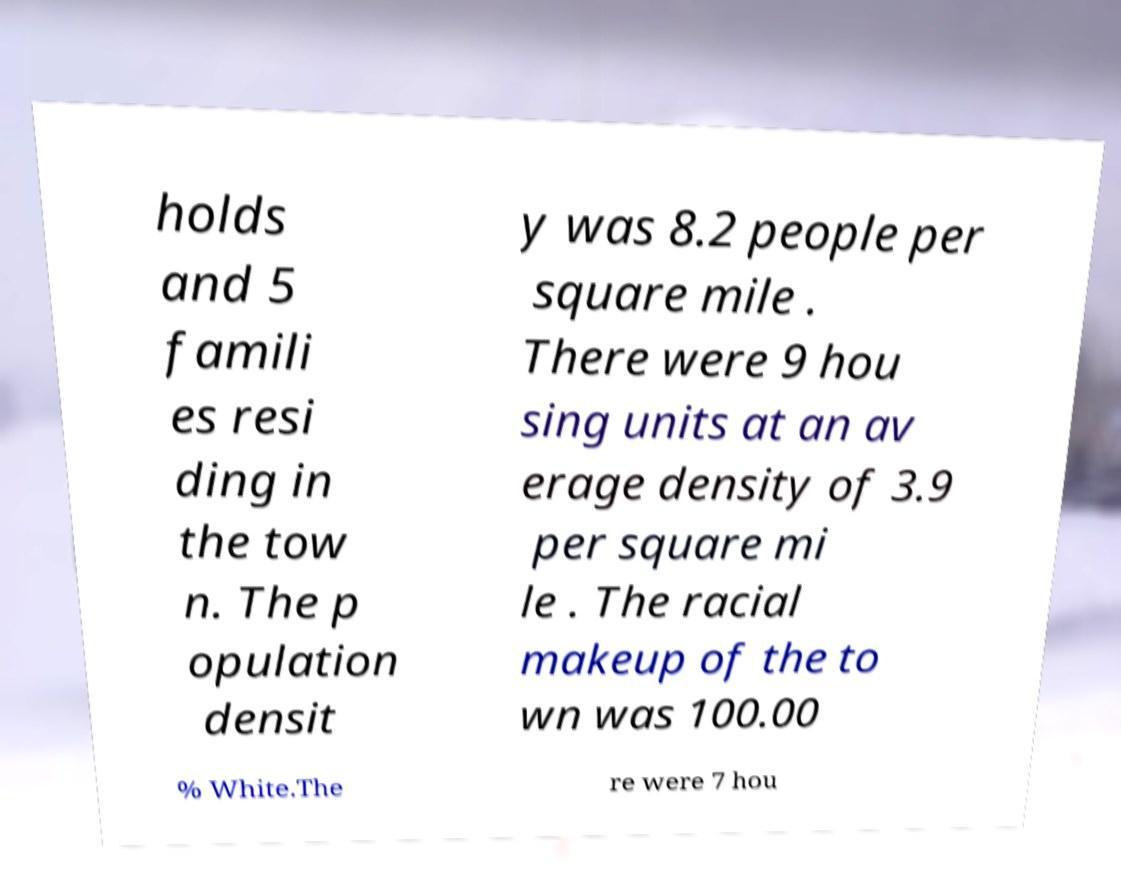What messages or text are displayed in this image? I need them in a readable, typed format. holds and 5 famili es resi ding in the tow n. The p opulation densit y was 8.2 people per square mile . There were 9 hou sing units at an av erage density of 3.9 per square mi le . The racial makeup of the to wn was 100.00 % White.The re were 7 hou 